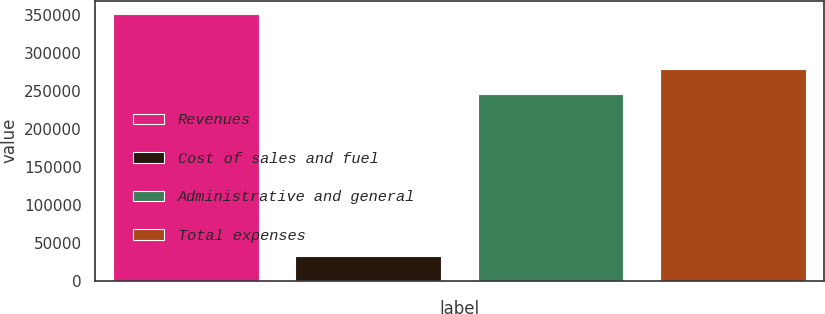Convert chart. <chart><loc_0><loc_0><loc_500><loc_500><bar_chart><fcel>Revenues<fcel>Cost of sales and fuel<fcel>Administrative and general<fcel>Total expenses<nl><fcel>352099<fcel>33094<fcel>246050<fcel>279144<nl></chart> 